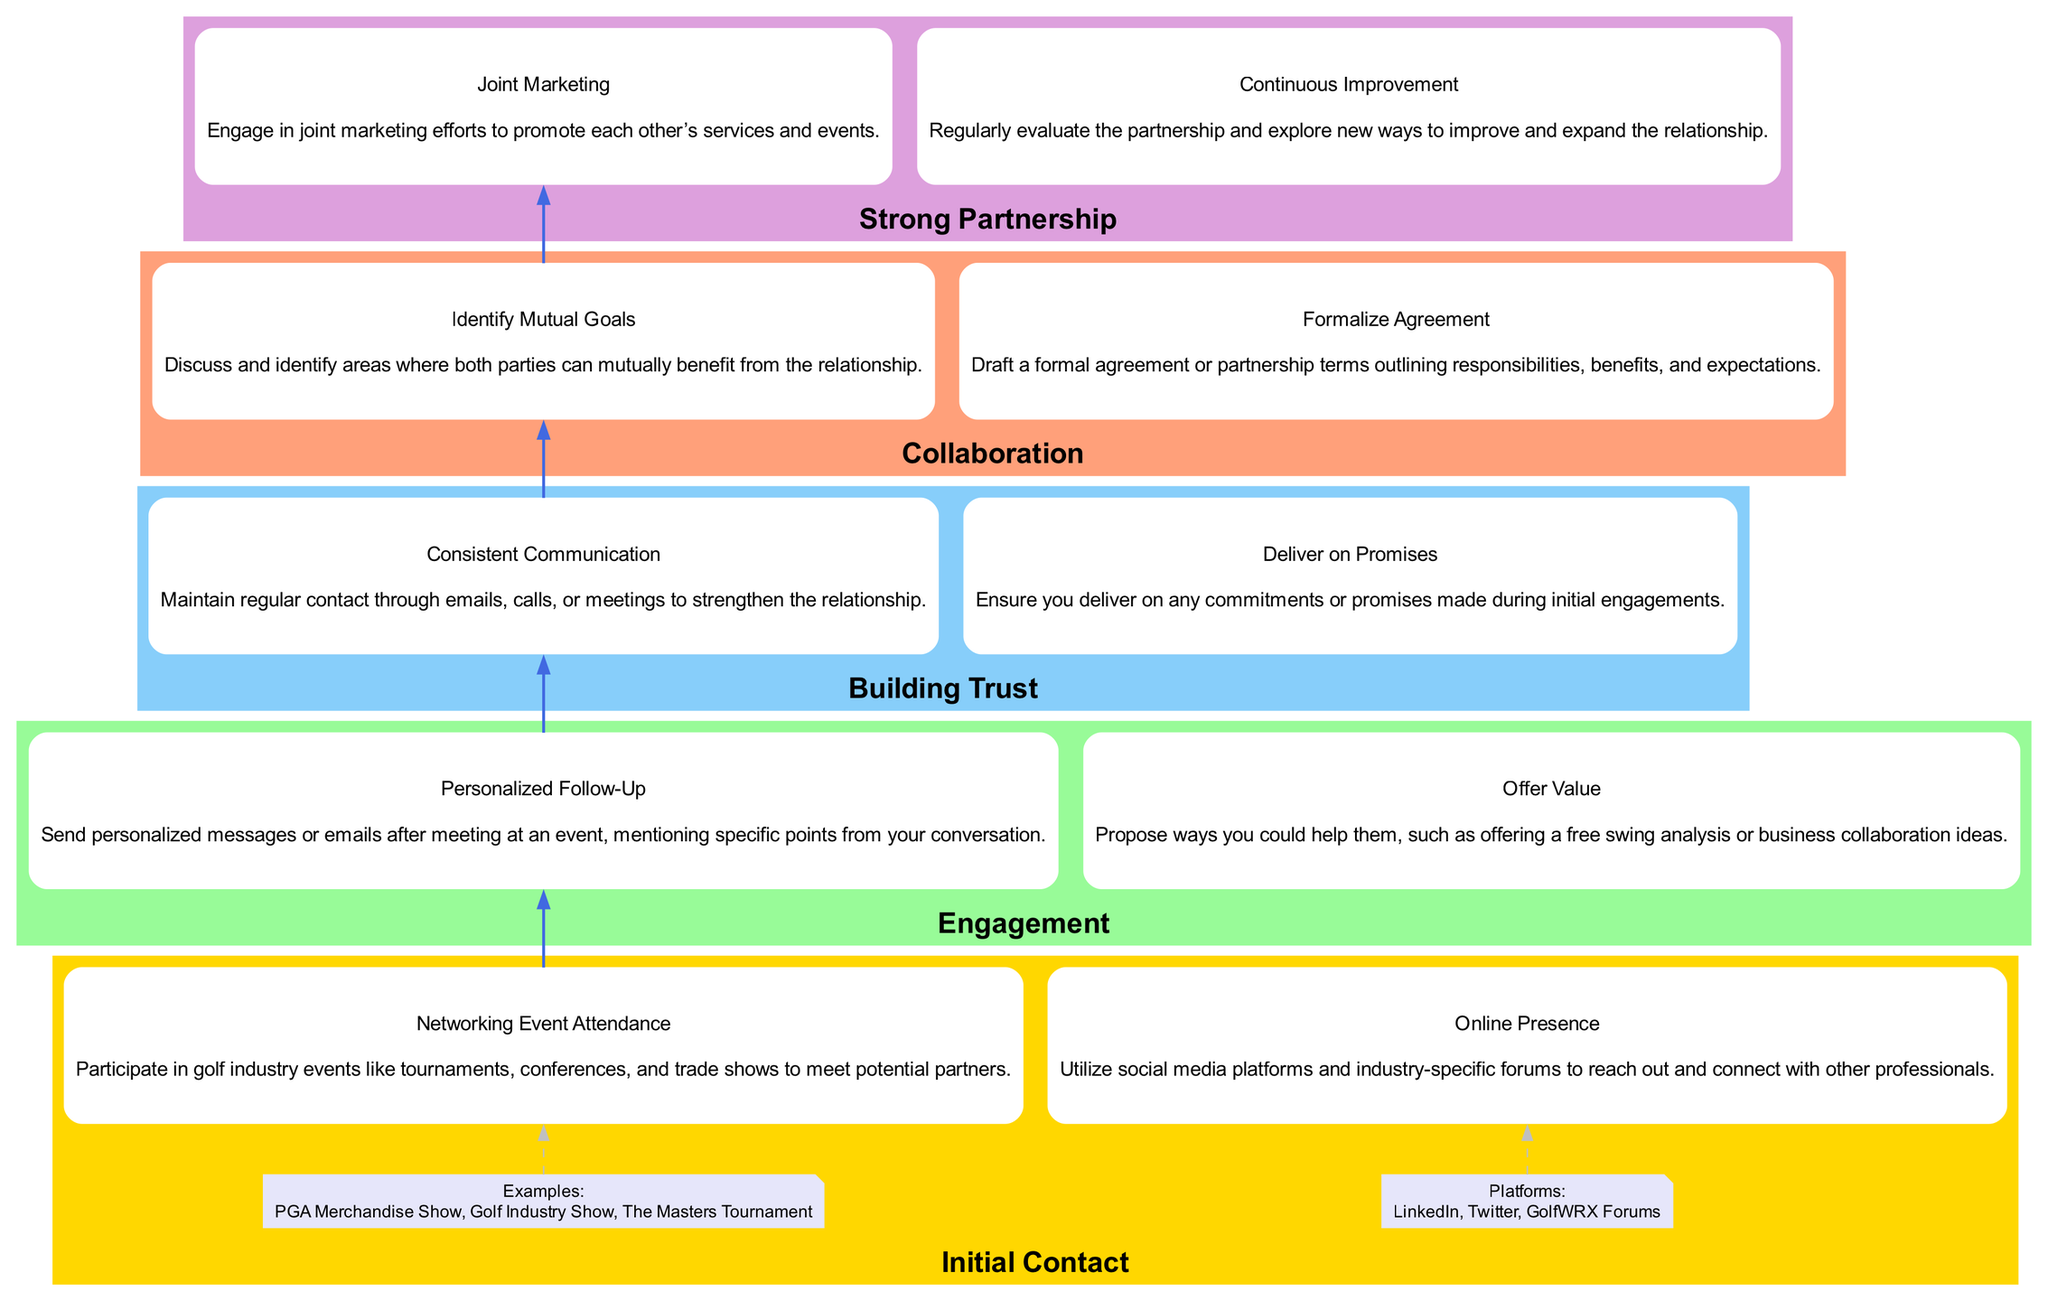What is the first step in building professional relationships in the golf industry? The first step, as indicated at the bottom of the diagram, is "Initial Contact."
Answer: Initial Contact How many main steps are outlined in the diagram? The diagram includes five main steps: Initial Contact, Engagement, Building Trust, Collaboration, and Strong Partnership.
Answer: Five What is one example of an event to attend for initial contact? Under "Networking Event Attendance," one example event is "The Masters Tournament."
Answer: The Masters Tournament What is a method suggested for maintaining communication in the Building Trust stage? The diagram specifies "Consistent Communication" as a method for maintaining communication, with a frequency of monthly check-ins or quarterly reviews.
Answer: Consistent Communication Which step follows Engagement in building professional relationships? The diagram shows that "Building Trust" follows "Engagement" in the flow of the steps.
Answer: Building Trust What should you do after meeting someone at a networking event? According to "Personalized Follow-Up," you should send personalized messages or emails after meeting.
Answer: Send personalized messages What type of activities are included under "Joint Marketing"? The diagram lists "Co-branded content," "Guest blogging," and "Shared social media campaigns" as example activities under "Joint Marketing."
Answer: Co-branded content, Guest blogging, Shared social media campaigns What is the primary purpose of "Deliver on Promises" in the Building Trust step? The purpose of "Deliver on Promises" is to ensure you fulfill commitments made during engagements, thereby strengthening the relationship.
Answer: Fulfill commitments How do you formalize a partnership according to the diagram? "Formalize Agreement" describes drafting a formal agreement or partnership terms outlining responsibilities.
Answer: Draft a formal agreement 